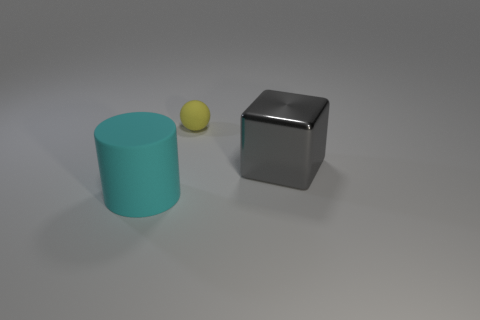The rubber thing left of the matte ball has what shape?
Give a very brief answer. Cylinder. Is the cyan thing made of the same material as the thing that is behind the large gray block?
Offer a terse response. Yes. What number of other objects are the same shape as the cyan matte thing?
Offer a very short reply. 0. Is the color of the metal cube the same as the large matte thing that is left of the matte ball?
Your answer should be very brief. No. Is there anything else that has the same material as the big gray thing?
Give a very brief answer. No. What is the shape of the object that is left of the matte thing that is behind the large cylinder?
Offer a very short reply. Cylinder. There is a thing on the right side of the tiny yellow matte sphere; is its shape the same as the cyan matte object?
Your answer should be very brief. No. Is the number of matte things on the right side of the cyan matte thing greater than the number of small rubber balls in front of the big shiny cube?
Provide a short and direct response. Yes. How many small yellow balls are behind the large object in front of the gray metallic thing?
Offer a very short reply. 1. How many other things are there of the same color as the matte cylinder?
Your answer should be very brief. 0. 